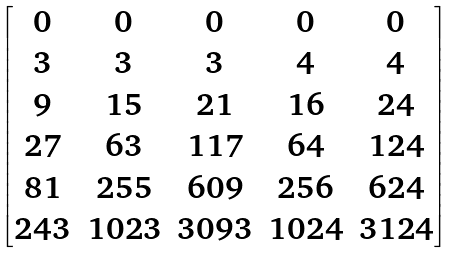Convert formula to latex. <formula><loc_0><loc_0><loc_500><loc_500>\begin{bmatrix} 0 & 0 & 0 & 0 & 0 \\ 3 & 3 & 3 & 4 & 4 \\ 9 & 1 5 & 2 1 & 1 6 & 2 4 \\ 2 7 & 6 3 & 1 1 7 & 6 4 & 1 2 4 \\ 8 1 & 2 5 5 & 6 0 9 & 2 5 6 & 6 2 4 \\ 2 4 3 & 1 0 2 3 & 3 0 9 3 & 1 0 2 4 & 3 1 2 4 \end{bmatrix}</formula> 